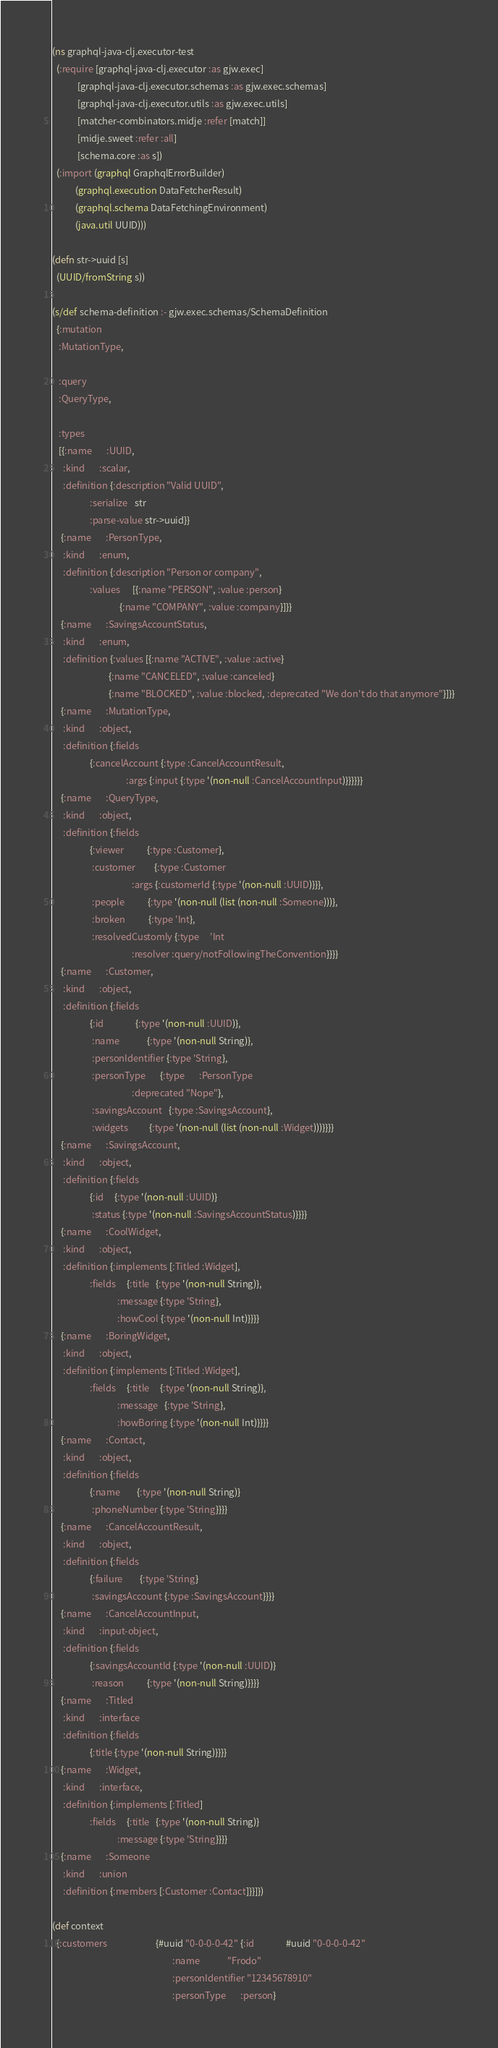Convert code to text. <code><loc_0><loc_0><loc_500><loc_500><_Clojure_>(ns graphql-java-clj.executor-test
  (:require [graphql-java-clj.executor :as gjw.exec]
            [graphql-java-clj.executor.schemas :as gjw.exec.schemas]
            [graphql-java-clj.executor.utils :as gjw.exec.utils]
            [matcher-combinators.midje :refer [match]]
            [midje.sweet :refer :all]
            [schema.core :as s])
  (:import (graphql GraphqlErrorBuilder)
           (graphql.execution DataFetcherResult)
           (graphql.schema DataFetchingEnvironment)
           (java.util UUID)))

(defn str->uuid [s]
  (UUID/fromString s))

(s/def schema-definition :- gjw.exec.schemas/SchemaDefinition
  {:mutation
   :MutationType,

   :query
   :QueryType,

   :types
   [{:name       :UUID,
     :kind       :scalar,
     :definition {:description "Valid UUID",
                  :serialize   str
                  :parse-value str->uuid}}
    {:name       :PersonType,
     :kind       :enum,
     :definition {:description "Person or company",
                  :values      [{:name "PERSON", :value :person}
                                {:name "COMPANY", :value :company}]}}
    {:name       :SavingsAccountStatus,
     :kind       :enum,
     :definition {:values [{:name "ACTIVE", :value :active}
                           {:name "CANCELED", :value :canceled}
                           {:name "BLOCKED", :value :blocked, :deprecated "We don't do that anymore"}]}}
    {:name       :MutationType,
     :kind       :object,
     :definition {:fields
                  {:cancelAccount {:type :CancelAccountResult,
                                   :args {:input {:type '(non-null :CancelAccountInput)}}}}}}
    {:name       :QueryType,
     :kind       :object,
     :definition {:fields
                  {:viewer           {:type :Customer},
                   :customer         {:type :Customer
                                      :args {:customerId {:type '(non-null :UUID)}}},
                   :people           {:type '(non-null (list (non-null :Someone)))},
                   :broken           {:type 'Int},
                   :resolvedCustomly {:type     'Int
                                      :resolver :query/notFollowingTheConvention}}}}
    {:name       :Customer,
     :kind       :object,
     :definition {:fields
                  {:id               {:type '(non-null :UUID)},
                   :name             {:type '(non-null String)},
                   :personIdentifier {:type 'String},
                   :personType       {:type       :PersonType
                                      :deprecated "Nope"},
                   :savingsAccount   {:type :SavingsAccount},
                   :widgets          {:type '(non-null (list (non-null :Widget)))}}}}
    {:name       :SavingsAccount,
     :kind       :object,
     :definition {:fields
                  {:id     {:type '(non-null :UUID)}
                   :status {:type '(non-null :SavingsAccountStatus)}}}}
    {:name       :CoolWidget,
     :kind       :object,
     :definition {:implements [:Titled :Widget],
                  :fields     {:title   {:type '(non-null String)},
                               :message {:type 'String},
                               :howCool {:type '(non-null Int)}}}}
    {:name       :BoringWidget,
     :kind       :object,
     :definition {:implements [:Titled :Widget],
                  :fields     {:title     {:type '(non-null String)},
                               :message   {:type 'String},
                               :howBoring {:type '(non-null Int)}}}}
    {:name       :Contact,
     :kind       :object,
     :definition {:fields
                  {:name        {:type '(non-null String)}
                   :phoneNumber {:type 'String}}}}
    {:name       :CancelAccountResult,
     :kind       :object,
     :definition {:fields
                  {:failure        {:type 'String}
                   :savingsAccount {:type :SavingsAccount}}}}
    {:name       :CancelAccountInput,
     :kind       :input-object,
     :definition {:fields
                  {:savingsAccountId {:type '(non-null :UUID)}
                   :reason           {:type '(non-null String)}}}}
    {:name       :Titled
     :kind       :interface
     :definition {:fields
                  {:title {:type '(non-null String)}}}}
    {:name       :Widget,
     :kind       :interface,
     :definition {:implements [:Titled]
                  :fields     {:title   {:type '(non-null String)}
                               :message {:type 'String}}}}
    {:name       :Someone
     :kind       :union
     :definition {:members [:Customer :Contact]}}]})

(def context
  {:customers                       {#uuid "0-0-0-0-42" {:id               #uuid "0-0-0-0-42"
                                                         :name             "Frodo"
                                                         :personIdentifier "12345678910"
                                                         :personType       :person}</code> 